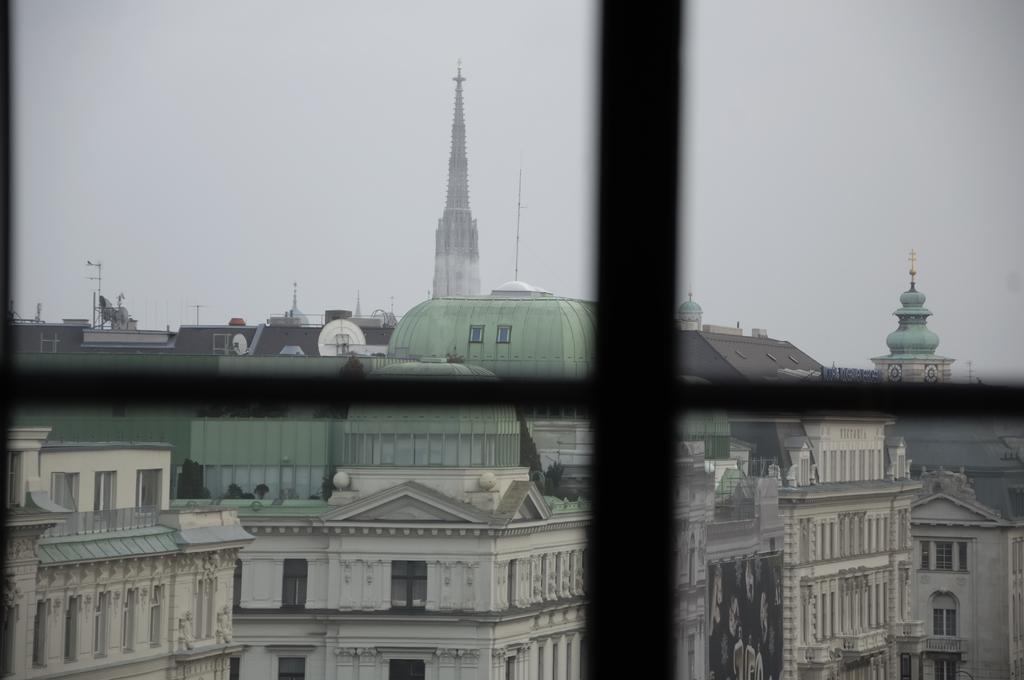What type of structure is present in the image? There is a glass window in the image. What can be seen through the glass window? Buildings and poles are visible through the glass window. What part of the natural environment can be seen through the glass window? The sky is visible through the glass window. What type of sweater is the tiger wearing while riding the train in the image? There is no train, sweater, or tiger present in the image. 